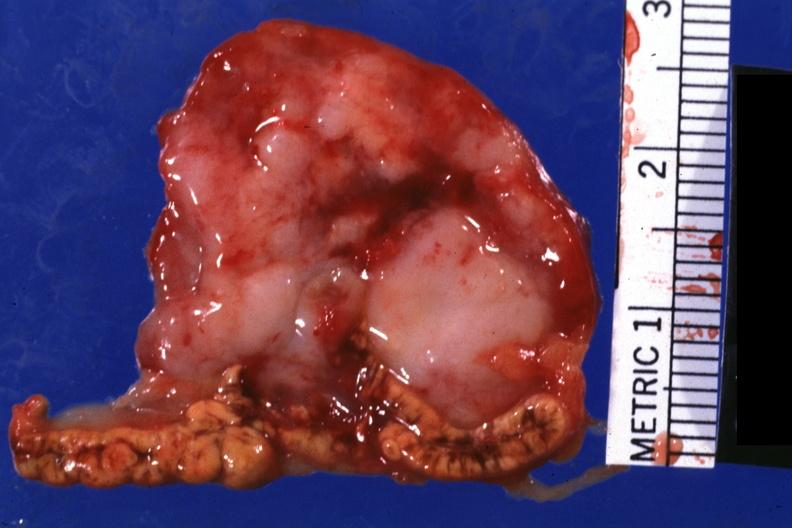s coronary artery anomalous origin left from pulmonary artery present?
Answer the question using a single word or phrase. No 